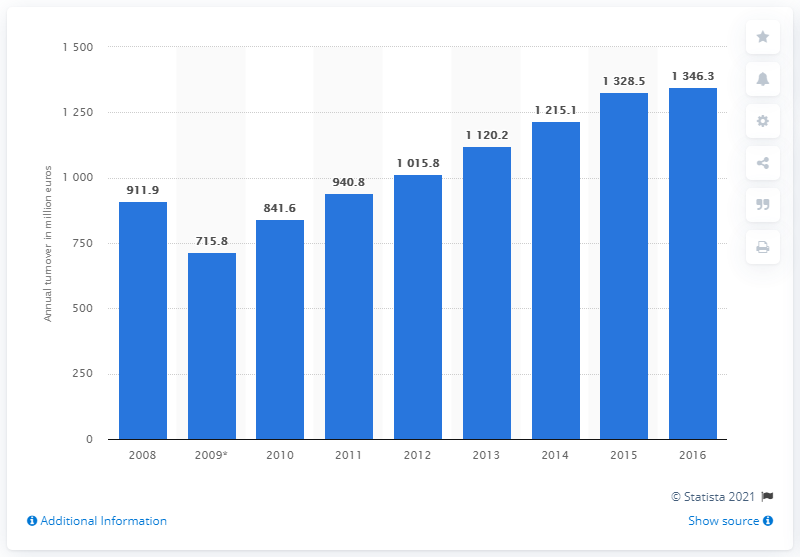Indicate a few pertinent items in this graphic. In 2016, the turnover of Romania's textile manufacturing industry was 1346.3 million units. 